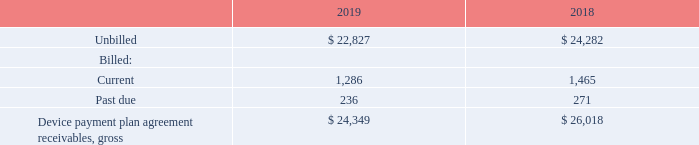Subsequent to origination, the delinquency and write-off experience is monitored as key credit quality indicators for the portfolio of device payment plan agreement receivables and fixed-term service plans. The extent of collection efforts with respect to a particular customer are based on the results of proprietary custom empirically derived internal behavioral-scoring models that analyze the customer’s past performance to predict the likelihood of the customer falling further delinquent.
These customer-scoring models assess a number of variables, including origination characteristics, customer account history and payment patterns. Based on the score derived from these models, accounts are grouped by risk category to determine the collection strategy to be applied to such accounts.
Collection performance results and the credit quality of device payment plan agreement receivables are continuously monitored based on a variety of metrics, including aging. An account is considered to be delinquent and in default status if there are unpaid charges remaining on the account on the day after the bill’s due date.
At December 31, 2019 and 2018, the balance and aging of the device payment plan agreement receivables on a gross basis was as follows:
How is the delinquency and write-off experience monitored? As key credit quality indicators for the portfolio of device payment plan agreement receivables and fixed-term service plans. What does the customer-scoring models assess? Origination characteristics, customer account history, payment patterns. What was the unbilled in 2019? $ 22,827. What was the increase / (decrease) in the unbilled from 2018 to 2019? 22,827 - 24,282
Answer: -1455. What was the average current billed for 2018 and 2019? (1,286 + 1,465) / 2
Answer: 1375.5. What was the increase / (decrease) in the past due from 2018 to 2019? 236 - 271
Answer: -35. 